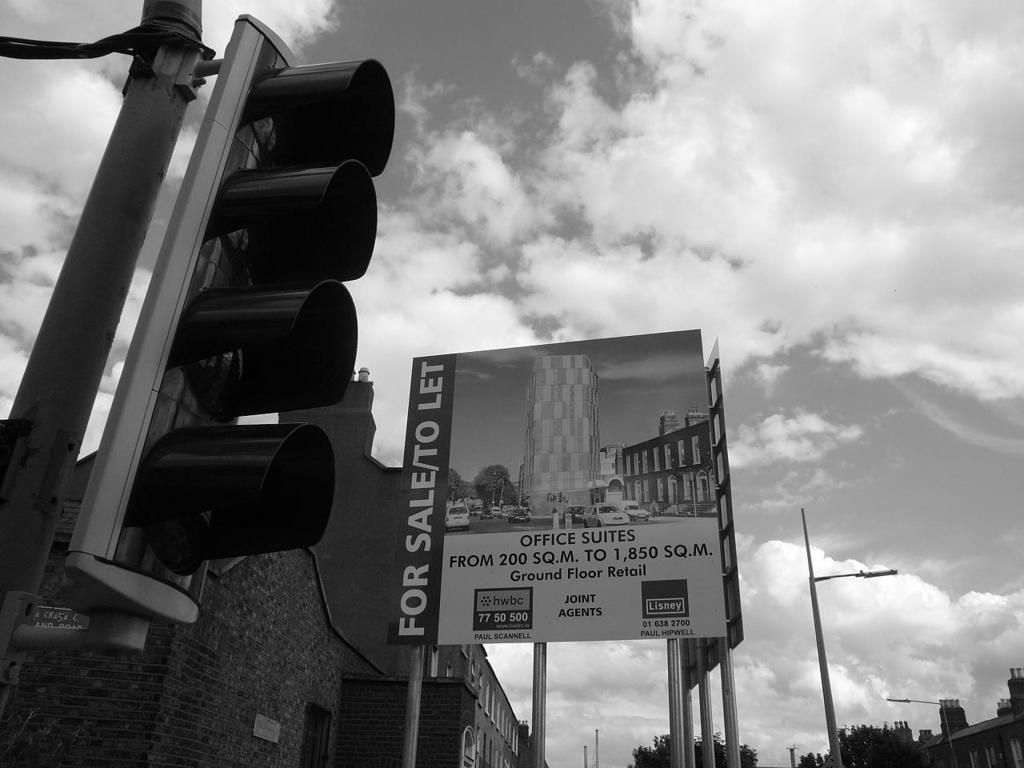<image>
Describe the image concisely. A black and white picture of a large sign that says for sale/to let. 